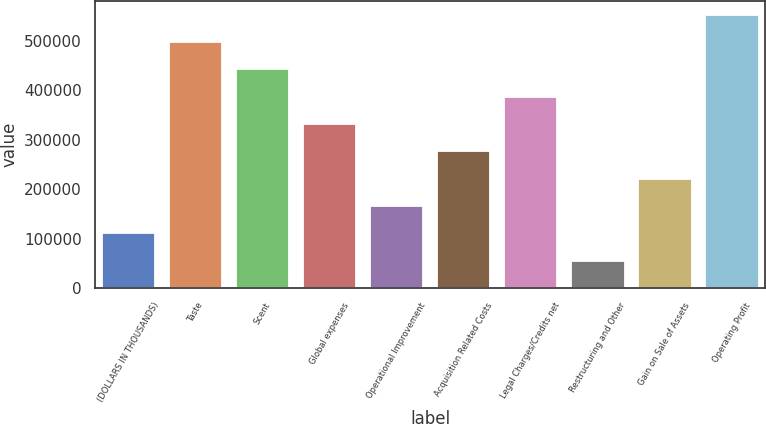<chart> <loc_0><loc_0><loc_500><loc_500><bar_chart><fcel>(DOLLARS IN THOUSANDS)<fcel>Taste<fcel>Scent<fcel>Global expenses<fcel>Operational Improvement<fcel>Acquisition Related Costs<fcel>Legal Charges/Credits net<fcel>Restructuring and Other<fcel>Gain on Sale of Assets<fcel>Operating Profit<nl><fcel>110605<fcel>497661<fcel>442368<fcel>331780<fcel>165899<fcel>276486<fcel>387074<fcel>55311.4<fcel>221193<fcel>552955<nl></chart> 